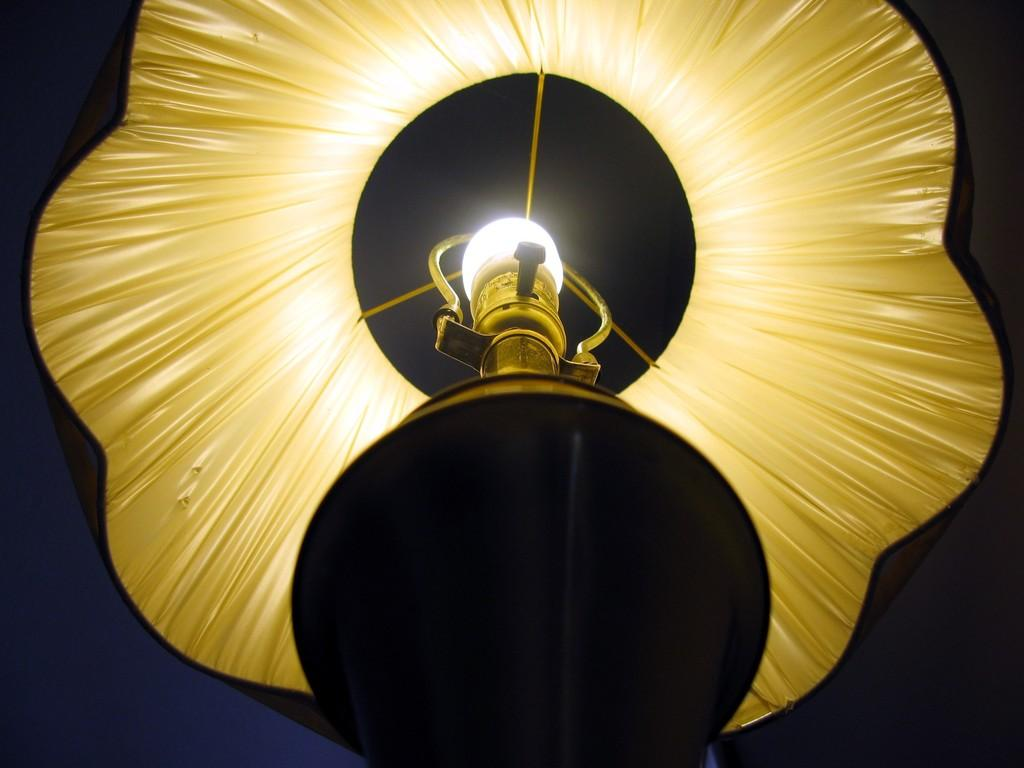What object in the image is providing light? There is a bed lamp in the image that is lighted. From what angle is the image taken? The image is taken from a perspective below the bed lamp. Can you describe the lighting condition in the image? The bed lamp is providing light, so the lighting condition is well-lit. What type of substance can be seen floating in the clouds in the image? There are no clouds or substances visible in the image; it features a bed lamp from a perspective below it. 